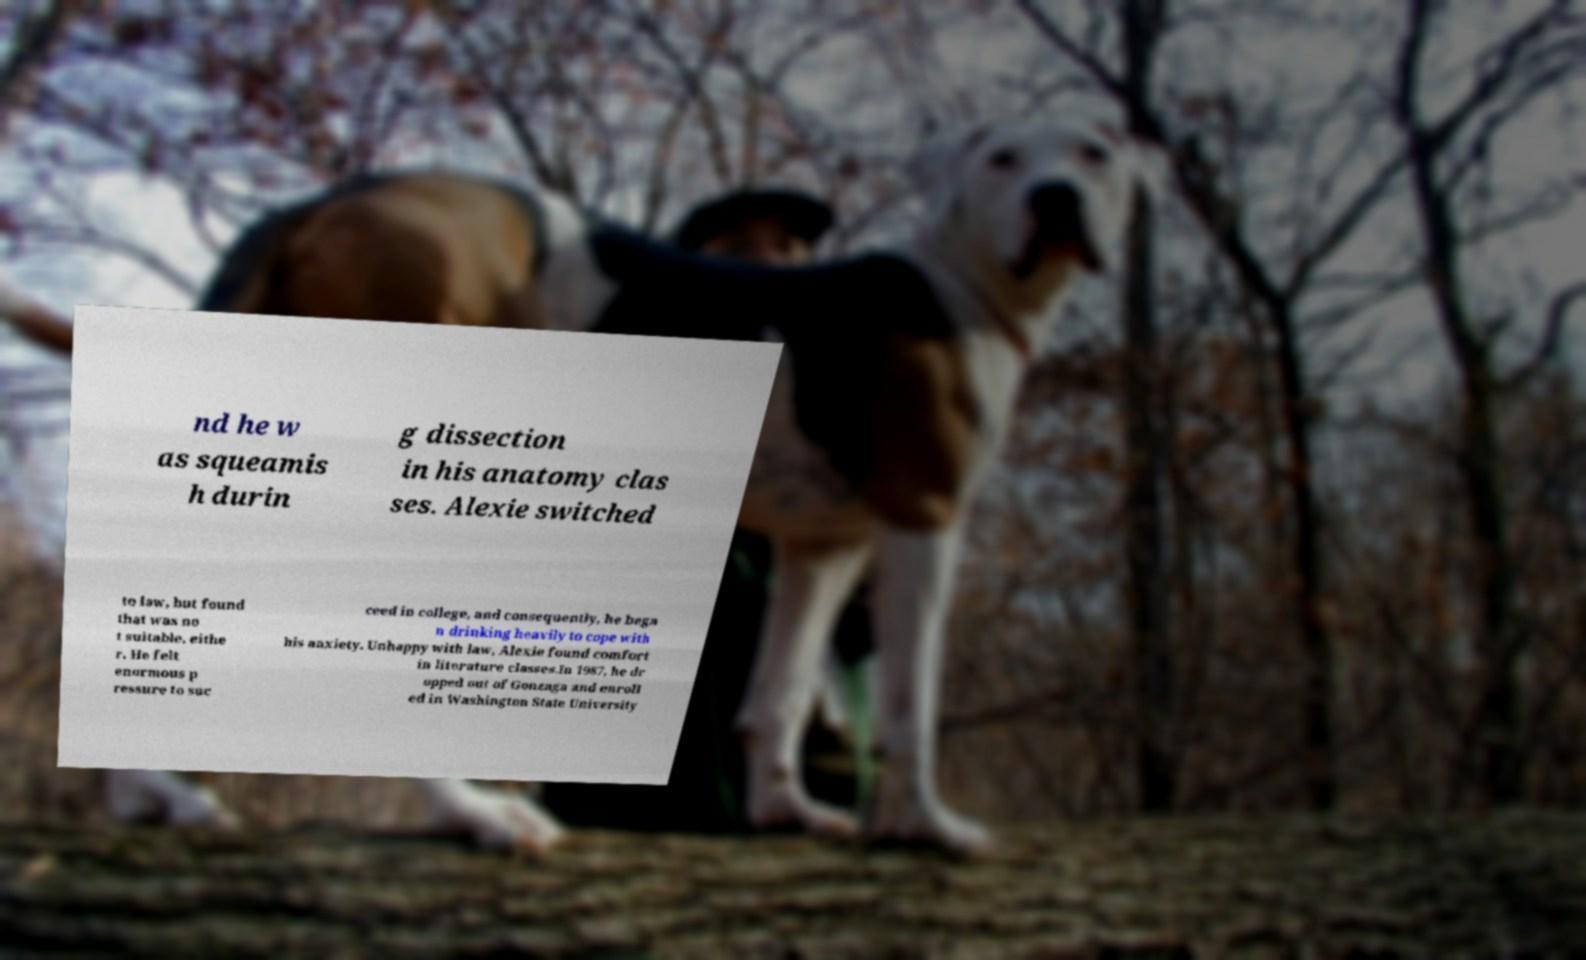Please identify and transcribe the text found in this image. nd he w as squeamis h durin g dissection in his anatomy clas ses. Alexie switched to law, but found that was no t suitable, eithe r. He felt enormous p ressure to suc ceed in college, and consequently, he bega n drinking heavily to cope with his anxiety. Unhappy with law, Alexie found comfort in literature classes.In 1987, he dr opped out of Gonzaga and enroll ed in Washington State University 